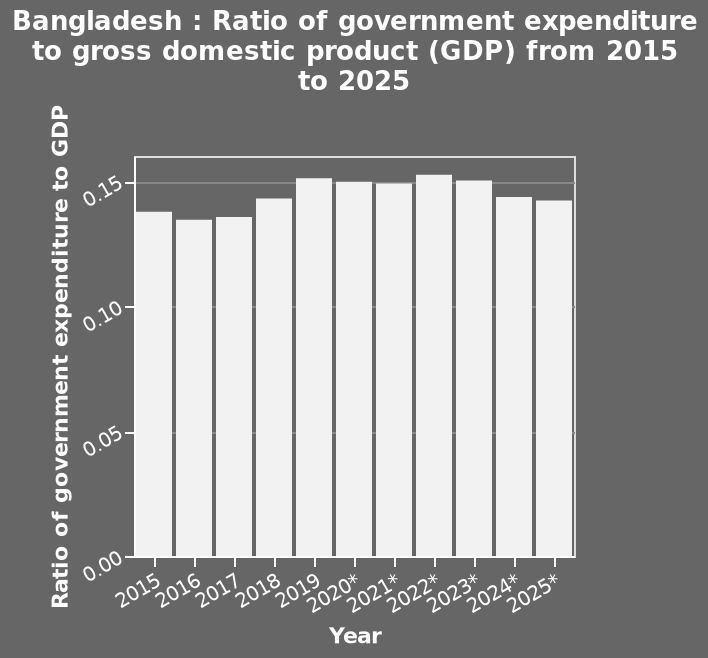<image>
please enumerates aspects of the construction of the chart Here a is a bar diagram labeled Bangladesh : Ratio of government expenditure to gross domestic product (GDP) from 2015 to 2025. The y-axis plots Ratio of government expenditure to GDP while the x-axis plots Year. What is the range of years shown in the bar diagram? The range of years shown in the bar diagram is from 2015 to 2025. Is the range of years shown in the bar diagram from 2016 to 2026? No.The range of years shown in the bar diagram is from 2015 to 2025. 